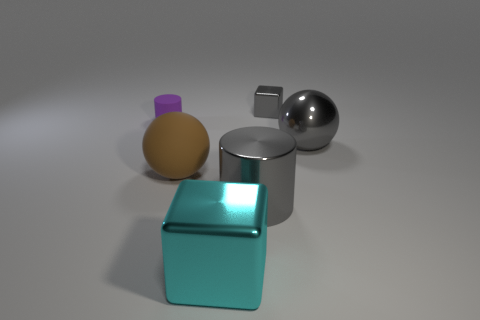Add 1 brown matte blocks. How many brown matte blocks exist? 1 Add 3 small things. How many objects exist? 9 Subtract all purple cylinders. How many cylinders are left? 1 Subtract 1 gray balls. How many objects are left? 5 Subtract 2 cubes. How many cubes are left? 0 Subtract all purple spheres. Subtract all brown cylinders. How many spheres are left? 2 Subtract all brown cylinders. How many brown balls are left? 1 Subtract all purple things. Subtract all big cyan objects. How many objects are left? 4 Add 6 purple rubber cylinders. How many purple rubber cylinders are left? 7 